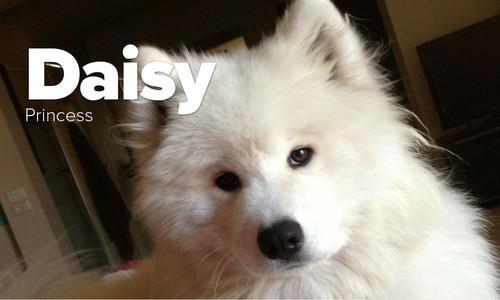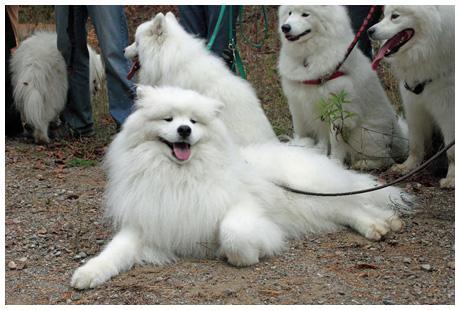The first image is the image on the left, the second image is the image on the right. Analyze the images presented: Is the assertion "One image has a dog wearing more than just a collar or leash." valid? Answer yes or no. No. The first image is the image on the left, the second image is the image on the right. Examine the images to the left and right. Is the description "In at least one image you can see at least one human wearing jeans feeding no less than 6 white dogs." accurate? Answer yes or no. No. 